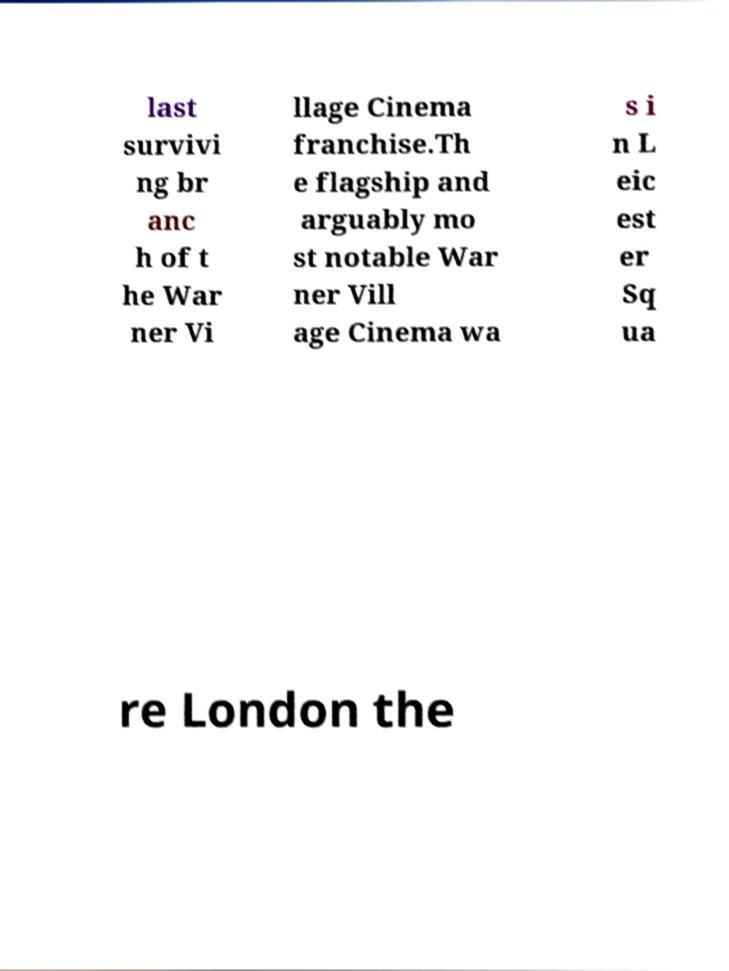For documentation purposes, I need the text within this image transcribed. Could you provide that? last survivi ng br anc h of t he War ner Vi llage Cinema franchise.Th e flagship and arguably mo st notable War ner Vill age Cinema wa s i n L eic est er Sq ua re London the 